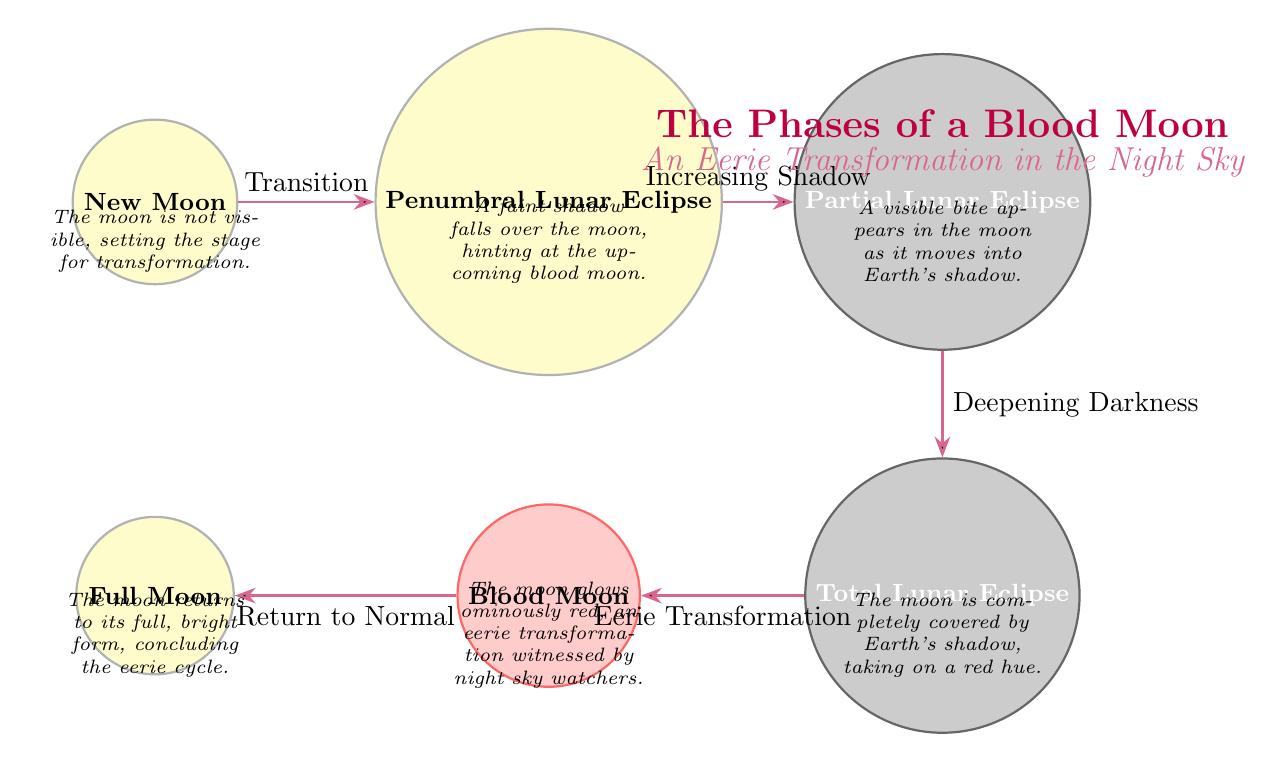What is the first phase of the blood moon? The diagram lists the phases of the blood moon starting with "New Moon" at the far left.
Answer: New Moon How many main phases are there in the blood moon sequence? By counting the distinct phases listed in the diagram, we see there are six: New Moon, Penumbral Lunar Eclipse, Partial Lunar Eclipse, Total Lunar Eclipse, Blood Moon, and Full Moon.
Answer: 6 What happens during the "Total Lunar Eclipse"? The description under the "Total Lunar Eclipse" node states that the moon is completely covered by Earth's shadow, taking on a red hue.
Answer: The moon is completely covered by Earth's shadow, taking on a red hue What transition occurs after the "Blood Moon"? The diagram shows an arrow labeled "Return to Normal" leading from the "Blood Moon" phase to the "Full Moon" phase.
Answer: Return to Normal What color does the moon exhibit during the "Blood Moon"? According to the descriptor for the "Blood Moon," it states that the moon glows ominously red.
Answer: Red What key transition occurs between the "Partial Lunar Eclipse" and "Total Lunar Eclipse"? The diagram highlights the transition by labeling it "Deepening Darkness," indicating that as the eclipse proceeds, darkness increases.
Answer: Deepening Darkness Which phase directly precedes the "Penumbral Lunar Eclipse"? The diagram shows an arrow moving from "New Moon" to "Penumbral Lunar Eclipse," indicating that "New Moon" is the direct predecessor.
Answer: New Moon What visual feature is noted at the "Partial Lunar Eclipse" phase? The description under the "Partial Lunar Eclipse" states that a visible bite appears in the moon as it moves into Earth's shadow.
Answer: A visible bite appears in the moon 